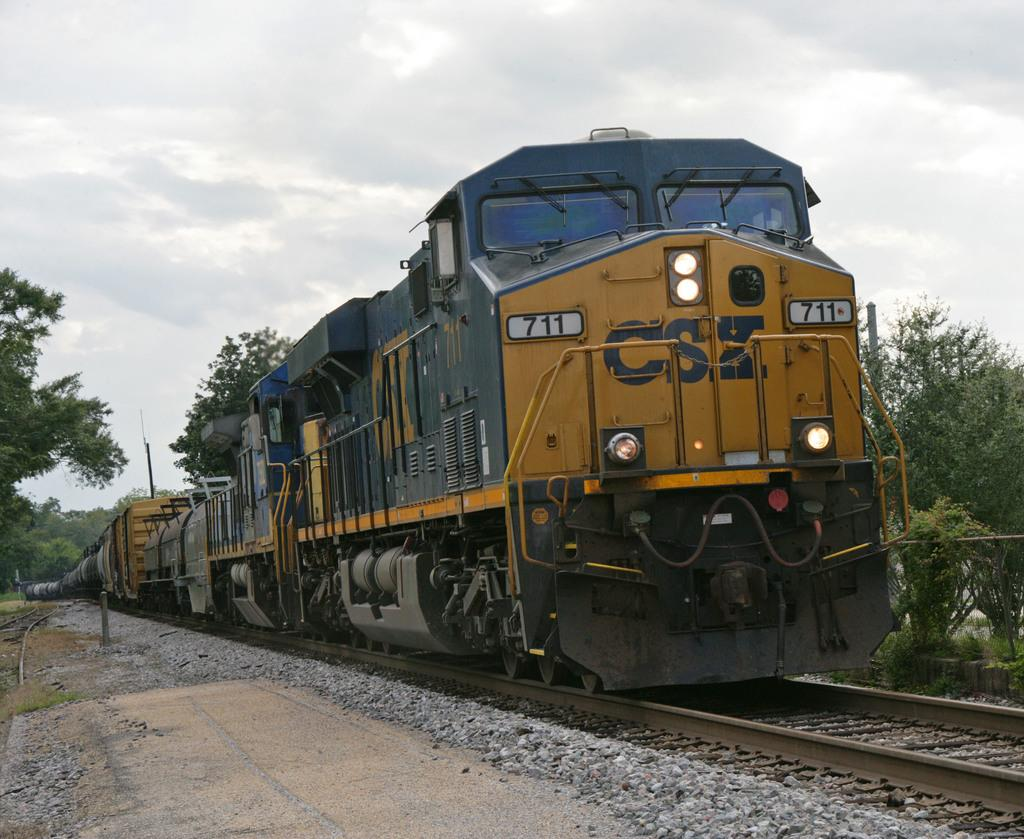What is the main subject in the middle of the image? There is a train in the middle of the image. What can be seen on either side of the train? There are trees on either side of the image. How would you describe the sky in the image? The sky is cloudy in the image. What type of treatment is being administered to the trucks in the image? There are no trucks present in the image, so no treatment can be administered. 